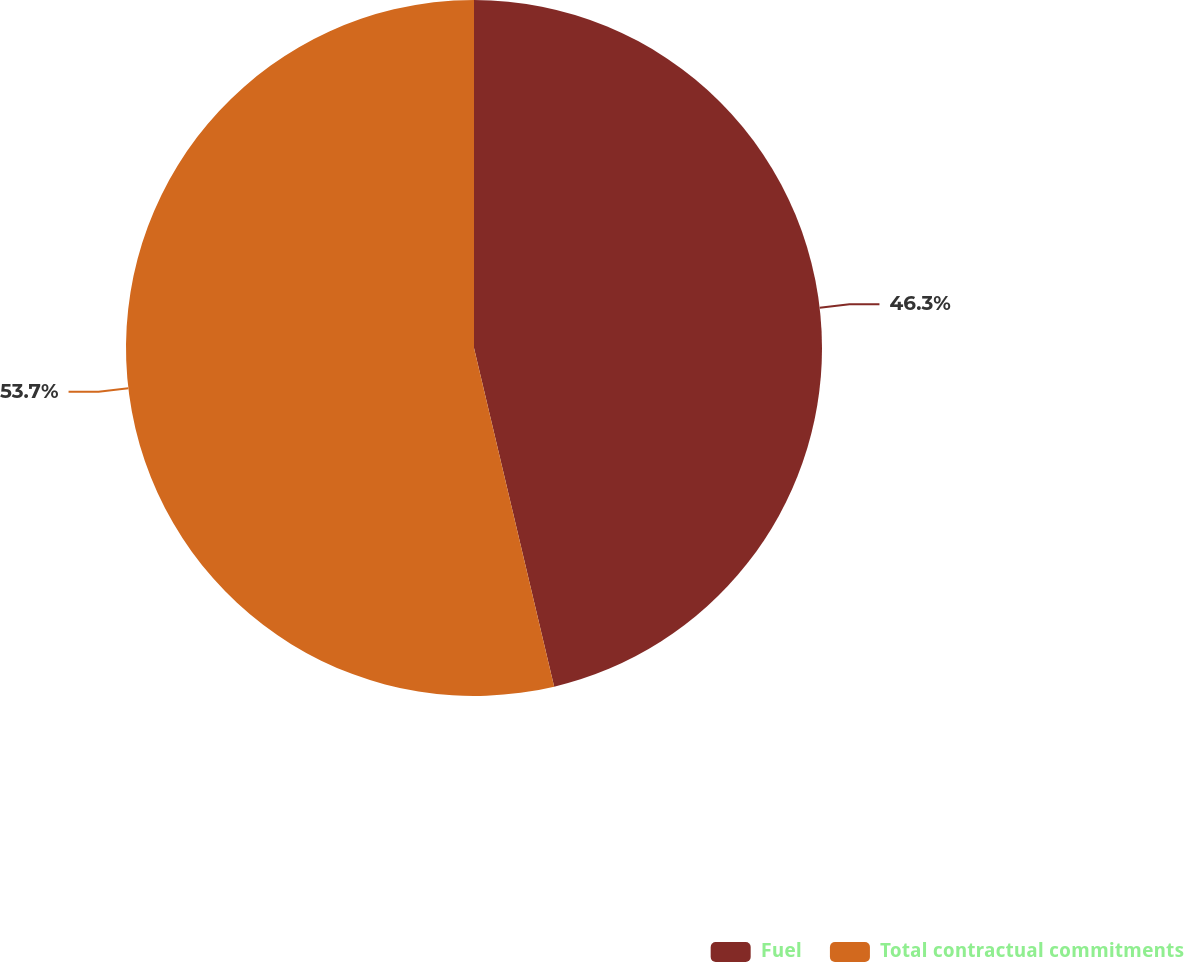<chart> <loc_0><loc_0><loc_500><loc_500><pie_chart><fcel>Fuel<fcel>Total contractual commitments<nl><fcel>46.3%<fcel>53.7%<nl></chart> 